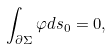Convert formula to latex. <formula><loc_0><loc_0><loc_500><loc_500>\int _ { \partial \Sigma } \varphi d s _ { 0 } = 0 ,</formula> 